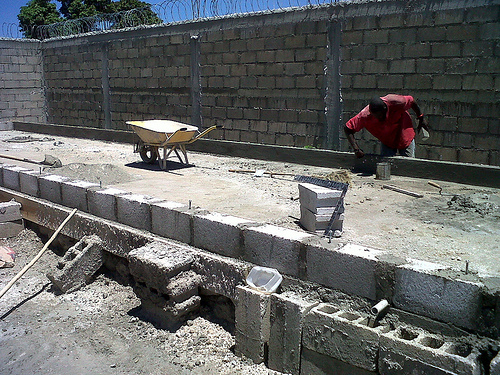<image>
Can you confirm if the man is behind the wheelbarrow? No. The man is not behind the wheelbarrow. From this viewpoint, the man appears to be positioned elsewhere in the scene. Where is the brick in relation to the man? Is it next to the man? No. The brick is not positioned next to the man. They are located in different areas of the scene. 